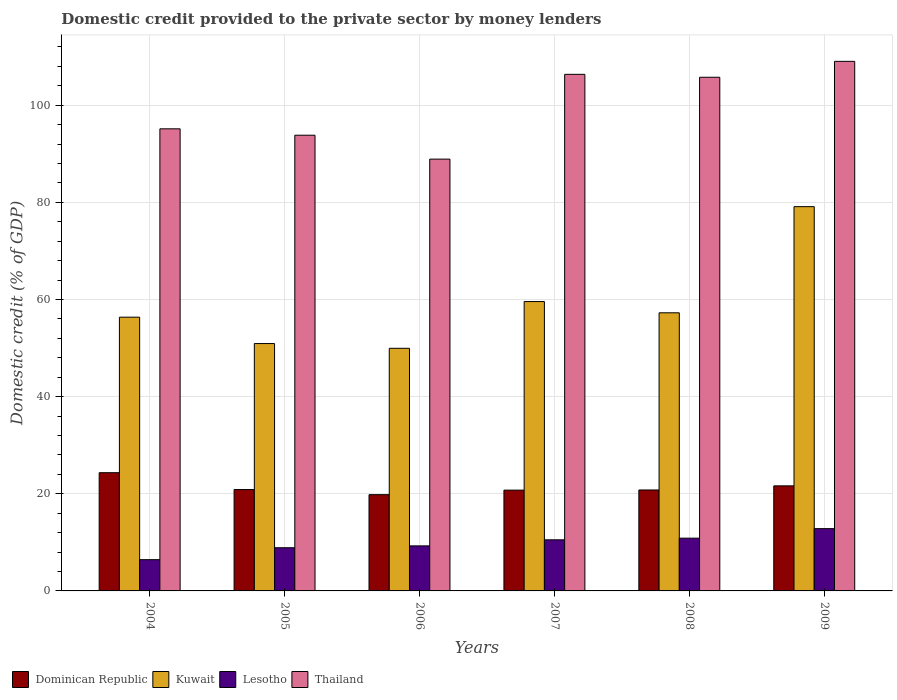How many bars are there on the 5th tick from the left?
Ensure brevity in your answer.  4. How many bars are there on the 6th tick from the right?
Make the answer very short. 4. What is the label of the 1st group of bars from the left?
Provide a succinct answer. 2004. What is the domestic credit provided to the private sector by money lenders in Thailand in 2004?
Give a very brief answer. 95.14. Across all years, what is the maximum domestic credit provided to the private sector by money lenders in Thailand?
Ensure brevity in your answer.  109.04. Across all years, what is the minimum domestic credit provided to the private sector by money lenders in Thailand?
Your answer should be compact. 88.91. In which year was the domestic credit provided to the private sector by money lenders in Kuwait maximum?
Provide a short and direct response. 2009. What is the total domestic credit provided to the private sector by money lenders in Thailand in the graph?
Ensure brevity in your answer.  599.04. What is the difference between the domestic credit provided to the private sector by money lenders in Kuwait in 2005 and that in 2009?
Offer a terse response. -28.19. What is the difference between the domestic credit provided to the private sector by money lenders in Dominican Republic in 2007 and the domestic credit provided to the private sector by money lenders in Kuwait in 2006?
Ensure brevity in your answer.  -29.2. What is the average domestic credit provided to the private sector by money lenders in Thailand per year?
Your answer should be very brief. 99.84. In the year 2009, what is the difference between the domestic credit provided to the private sector by money lenders in Lesotho and domestic credit provided to the private sector by money lenders in Kuwait?
Provide a succinct answer. -66.29. In how many years, is the domestic credit provided to the private sector by money lenders in Dominican Republic greater than 96 %?
Provide a short and direct response. 0. What is the ratio of the domestic credit provided to the private sector by money lenders in Lesotho in 2004 to that in 2006?
Your answer should be very brief. 0.69. What is the difference between the highest and the second highest domestic credit provided to the private sector by money lenders in Lesotho?
Offer a very short reply. 1.96. What is the difference between the highest and the lowest domestic credit provided to the private sector by money lenders in Dominican Republic?
Give a very brief answer. 4.52. Is the sum of the domestic credit provided to the private sector by money lenders in Lesotho in 2004 and 2009 greater than the maximum domestic credit provided to the private sector by money lenders in Thailand across all years?
Ensure brevity in your answer.  No. What does the 2nd bar from the left in 2007 represents?
Keep it short and to the point. Kuwait. What does the 2nd bar from the right in 2004 represents?
Ensure brevity in your answer.  Lesotho. Are all the bars in the graph horizontal?
Offer a very short reply. No. Are the values on the major ticks of Y-axis written in scientific E-notation?
Offer a terse response. No. Does the graph contain any zero values?
Make the answer very short. No. How many legend labels are there?
Give a very brief answer. 4. How are the legend labels stacked?
Provide a succinct answer. Horizontal. What is the title of the graph?
Ensure brevity in your answer.  Domestic credit provided to the private sector by money lenders. Does "Norway" appear as one of the legend labels in the graph?
Offer a terse response. No. What is the label or title of the Y-axis?
Make the answer very short. Domestic credit (% of GDP). What is the Domestic credit (% of GDP) in Dominican Republic in 2004?
Give a very brief answer. 24.34. What is the Domestic credit (% of GDP) of Kuwait in 2004?
Provide a succinct answer. 56.36. What is the Domestic credit (% of GDP) of Lesotho in 2004?
Offer a terse response. 6.44. What is the Domestic credit (% of GDP) of Thailand in 2004?
Give a very brief answer. 95.14. What is the Domestic credit (% of GDP) in Dominican Republic in 2005?
Offer a very short reply. 20.87. What is the Domestic credit (% of GDP) of Kuwait in 2005?
Keep it short and to the point. 50.93. What is the Domestic credit (% of GDP) in Lesotho in 2005?
Provide a short and direct response. 8.89. What is the Domestic credit (% of GDP) of Thailand in 2005?
Your answer should be compact. 93.83. What is the Domestic credit (% of GDP) of Dominican Republic in 2006?
Give a very brief answer. 19.82. What is the Domestic credit (% of GDP) in Kuwait in 2006?
Your answer should be very brief. 49.95. What is the Domestic credit (% of GDP) in Lesotho in 2006?
Keep it short and to the point. 9.27. What is the Domestic credit (% of GDP) of Thailand in 2006?
Make the answer very short. 88.91. What is the Domestic credit (% of GDP) of Dominican Republic in 2007?
Your answer should be compact. 20.75. What is the Domestic credit (% of GDP) in Kuwait in 2007?
Give a very brief answer. 59.58. What is the Domestic credit (% of GDP) in Lesotho in 2007?
Keep it short and to the point. 10.52. What is the Domestic credit (% of GDP) of Thailand in 2007?
Your answer should be compact. 106.36. What is the Domestic credit (% of GDP) in Dominican Republic in 2008?
Your answer should be very brief. 20.79. What is the Domestic credit (% of GDP) of Kuwait in 2008?
Your answer should be very brief. 57.26. What is the Domestic credit (% of GDP) of Lesotho in 2008?
Keep it short and to the point. 10.86. What is the Domestic credit (% of GDP) in Thailand in 2008?
Offer a very short reply. 105.76. What is the Domestic credit (% of GDP) in Dominican Republic in 2009?
Offer a terse response. 21.63. What is the Domestic credit (% of GDP) of Kuwait in 2009?
Give a very brief answer. 79.12. What is the Domestic credit (% of GDP) in Lesotho in 2009?
Offer a terse response. 12.82. What is the Domestic credit (% of GDP) of Thailand in 2009?
Keep it short and to the point. 109.04. Across all years, what is the maximum Domestic credit (% of GDP) in Dominican Republic?
Make the answer very short. 24.34. Across all years, what is the maximum Domestic credit (% of GDP) of Kuwait?
Offer a very short reply. 79.12. Across all years, what is the maximum Domestic credit (% of GDP) in Lesotho?
Give a very brief answer. 12.82. Across all years, what is the maximum Domestic credit (% of GDP) of Thailand?
Keep it short and to the point. 109.04. Across all years, what is the minimum Domestic credit (% of GDP) of Dominican Republic?
Your answer should be compact. 19.82. Across all years, what is the minimum Domestic credit (% of GDP) of Kuwait?
Ensure brevity in your answer.  49.95. Across all years, what is the minimum Domestic credit (% of GDP) of Lesotho?
Provide a succinct answer. 6.44. Across all years, what is the minimum Domestic credit (% of GDP) in Thailand?
Offer a terse response. 88.91. What is the total Domestic credit (% of GDP) in Dominican Republic in the graph?
Ensure brevity in your answer.  128.2. What is the total Domestic credit (% of GDP) in Kuwait in the graph?
Ensure brevity in your answer.  353.21. What is the total Domestic credit (% of GDP) in Lesotho in the graph?
Keep it short and to the point. 58.81. What is the total Domestic credit (% of GDP) of Thailand in the graph?
Your response must be concise. 599.04. What is the difference between the Domestic credit (% of GDP) of Dominican Republic in 2004 and that in 2005?
Provide a short and direct response. 3.47. What is the difference between the Domestic credit (% of GDP) in Kuwait in 2004 and that in 2005?
Make the answer very short. 5.43. What is the difference between the Domestic credit (% of GDP) of Lesotho in 2004 and that in 2005?
Make the answer very short. -2.46. What is the difference between the Domestic credit (% of GDP) of Thailand in 2004 and that in 2005?
Give a very brief answer. 1.31. What is the difference between the Domestic credit (% of GDP) of Dominican Republic in 2004 and that in 2006?
Keep it short and to the point. 4.52. What is the difference between the Domestic credit (% of GDP) of Kuwait in 2004 and that in 2006?
Give a very brief answer. 6.41. What is the difference between the Domestic credit (% of GDP) in Lesotho in 2004 and that in 2006?
Make the answer very short. -2.84. What is the difference between the Domestic credit (% of GDP) of Thailand in 2004 and that in 2006?
Offer a very short reply. 6.24. What is the difference between the Domestic credit (% of GDP) of Dominican Republic in 2004 and that in 2007?
Offer a terse response. 3.59. What is the difference between the Domestic credit (% of GDP) in Kuwait in 2004 and that in 2007?
Your answer should be very brief. -3.22. What is the difference between the Domestic credit (% of GDP) in Lesotho in 2004 and that in 2007?
Ensure brevity in your answer.  -4.09. What is the difference between the Domestic credit (% of GDP) in Thailand in 2004 and that in 2007?
Make the answer very short. -11.22. What is the difference between the Domestic credit (% of GDP) of Dominican Republic in 2004 and that in 2008?
Provide a short and direct response. 3.56. What is the difference between the Domestic credit (% of GDP) of Kuwait in 2004 and that in 2008?
Provide a short and direct response. -0.9. What is the difference between the Domestic credit (% of GDP) in Lesotho in 2004 and that in 2008?
Your response must be concise. -4.43. What is the difference between the Domestic credit (% of GDP) in Thailand in 2004 and that in 2008?
Provide a succinct answer. -10.62. What is the difference between the Domestic credit (% of GDP) in Dominican Republic in 2004 and that in 2009?
Offer a terse response. 2.71. What is the difference between the Domestic credit (% of GDP) in Kuwait in 2004 and that in 2009?
Your response must be concise. -22.76. What is the difference between the Domestic credit (% of GDP) in Lesotho in 2004 and that in 2009?
Give a very brief answer. -6.39. What is the difference between the Domestic credit (% of GDP) of Thailand in 2004 and that in 2009?
Your response must be concise. -13.89. What is the difference between the Domestic credit (% of GDP) in Dominican Republic in 2005 and that in 2006?
Your answer should be very brief. 1.05. What is the difference between the Domestic credit (% of GDP) of Kuwait in 2005 and that in 2006?
Your response must be concise. 0.98. What is the difference between the Domestic credit (% of GDP) in Lesotho in 2005 and that in 2006?
Ensure brevity in your answer.  -0.38. What is the difference between the Domestic credit (% of GDP) in Thailand in 2005 and that in 2006?
Your answer should be very brief. 4.92. What is the difference between the Domestic credit (% of GDP) of Dominican Republic in 2005 and that in 2007?
Give a very brief answer. 0.12. What is the difference between the Domestic credit (% of GDP) in Kuwait in 2005 and that in 2007?
Give a very brief answer. -8.65. What is the difference between the Domestic credit (% of GDP) of Lesotho in 2005 and that in 2007?
Your answer should be very brief. -1.63. What is the difference between the Domestic credit (% of GDP) in Thailand in 2005 and that in 2007?
Keep it short and to the point. -12.53. What is the difference between the Domestic credit (% of GDP) in Dominican Republic in 2005 and that in 2008?
Make the answer very short. 0.09. What is the difference between the Domestic credit (% of GDP) in Kuwait in 2005 and that in 2008?
Make the answer very short. -6.33. What is the difference between the Domestic credit (% of GDP) in Lesotho in 2005 and that in 2008?
Make the answer very short. -1.97. What is the difference between the Domestic credit (% of GDP) in Thailand in 2005 and that in 2008?
Provide a short and direct response. -11.93. What is the difference between the Domestic credit (% of GDP) of Dominican Republic in 2005 and that in 2009?
Provide a succinct answer. -0.76. What is the difference between the Domestic credit (% of GDP) in Kuwait in 2005 and that in 2009?
Provide a short and direct response. -28.19. What is the difference between the Domestic credit (% of GDP) in Lesotho in 2005 and that in 2009?
Provide a short and direct response. -3.93. What is the difference between the Domestic credit (% of GDP) of Thailand in 2005 and that in 2009?
Give a very brief answer. -15.21. What is the difference between the Domestic credit (% of GDP) in Dominican Republic in 2006 and that in 2007?
Ensure brevity in your answer.  -0.94. What is the difference between the Domestic credit (% of GDP) in Kuwait in 2006 and that in 2007?
Ensure brevity in your answer.  -9.63. What is the difference between the Domestic credit (% of GDP) of Lesotho in 2006 and that in 2007?
Provide a short and direct response. -1.25. What is the difference between the Domestic credit (% of GDP) of Thailand in 2006 and that in 2007?
Keep it short and to the point. -17.46. What is the difference between the Domestic credit (% of GDP) in Dominican Republic in 2006 and that in 2008?
Provide a short and direct response. -0.97. What is the difference between the Domestic credit (% of GDP) in Kuwait in 2006 and that in 2008?
Ensure brevity in your answer.  -7.31. What is the difference between the Domestic credit (% of GDP) of Lesotho in 2006 and that in 2008?
Offer a very short reply. -1.59. What is the difference between the Domestic credit (% of GDP) of Thailand in 2006 and that in 2008?
Provide a short and direct response. -16.85. What is the difference between the Domestic credit (% of GDP) of Dominican Republic in 2006 and that in 2009?
Make the answer very short. -1.81. What is the difference between the Domestic credit (% of GDP) of Kuwait in 2006 and that in 2009?
Give a very brief answer. -29.17. What is the difference between the Domestic credit (% of GDP) of Lesotho in 2006 and that in 2009?
Ensure brevity in your answer.  -3.55. What is the difference between the Domestic credit (% of GDP) of Thailand in 2006 and that in 2009?
Ensure brevity in your answer.  -20.13. What is the difference between the Domestic credit (% of GDP) of Dominican Republic in 2007 and that in 2008?
Offer a terse response. -0.03. What is the difference between the Domestic credit (% of GDP) in Kuwait in 2007 and that in 2008?
Provide a short and direct response. 2.31. What is the difference between the Domestic credit (% of GDP) of Lesotho in 2007 and that in 2008?
Your answer should be compact. -0.34. What is the difference between the Domestic credit (% of GDP) in Thailand in 2007 and that in 2008?
Give a very brief answer. 0.6. What is the difference between the Domestic credit (% of GDP) in Dominican Republic in 2007 and that in 2009?
Provide a succinct answer. -0.88. What is the difference between the Domestic credit (% of GDP) of Kuwait in 2007 and that in 2009?
Provide a short and direct response. -19.54. What is the difference between the Domestic credit (% of GDP) of Lesotho in 2007 and that in 2009?
Your response must be concise. -2.3. What is the difference between the Domestic credit (% of GDP) of Thailand in 2007 and that in 2009?
Your answer should be very brief. -2.67. What is the difference between the Domestic credit (% of GDP) in Dominican Republic in 2008 and that in 2009?
Provide a short and direct response. -0.85. What is the difference between the Domestic credit (% of GDP) of Kuwait in 2008 and that in 2009?
Keep it short and to the point. -21.85. What is the difference between the Domestic credit (% of GDP) in Lesotho in 2008 and that in 2009?
Provide a short and direct response. -1.96. What is the difference between the Domestic credit (% of GDP) of Thailand in 2008 and that in 2009?
Offer a terse response. -3.28. What is the difference between the Domestic credit (% of GDP) of Dominican Republic in 2004 and the Domestic credit (% of GDP) of Kuwait in 2005?
Keep it short and to the point. -26.59. What is the difference between the Domestic credit (% of GDP) of Dominican Republic in 2004 and the Domestic credit (% of GDP) of Lesotho in 2005?
Keep it short and to the point. 15.45. What is the difference between the Domestic credit (% of GDP) in Dominican Republic in 2004 and the Domestic credit (% of GDP) in Thailand in 2005?
Your response must be concise. -69.49. What is the difference between the Domestic credit (% of GDP) of Kuwait in 2004 and the Domestic credit (% of GDP) of Lesotho in 2005?
Your answer should be compact. 47.47. What is the difference between the Domestic credit (% of GDP) in Kuwait in 2004 and the Domestic credit (% of GDP) in Thailand in 2005?
Ensure brevity in your answer.  -37.47. What is the difference between the Domestic credit (% of GDP) of Lesotho in 2004 and the Domestic credit (% of GDP) of Thailand in 2005?
Keep it short and to the point. -87.39. What is the difference between the Domestic credit (% of GDP) of Dominican Republic in 2004 and the Domestic credit (% of GDP) of Kuwait in 2006?
Ensure brevity in your answer.  -25.61. What is the difference between the Domestic credit (% of GDP) in Dominican Republic in 2004 and the Domestic credit (% of GDP) in Lesotho in 2006?
Make the answer very short. 15.07. What is the difference between the Domestic credit (% of GDP) of Dominican Republic in 2004 and the Domestic credit (% of GDP) of Thailand in 2006?
Provide a succinct answer. -64.56. What is the difference between the Domestic credit (% of GDP) in Kuwait in 2004 and the Domestic credit (% of GDP) in Lesotho in 2006?
Your response must be concise. 47.09. What is the difference between the Domestic credit (% of GDP) in Kuwait in 2004 and the Domestic credit (% of GDP) in Thailand in 2006?
Provide a short and direct response. -32.54. What is the difference between the Domestic credit (% of GDP) of Lesotho in 2004 and the Domestic credit (% of GDP) of Thailand in 2006?
Offer a very short reply. -82.47. What is the difference between the Domestic credit (% of GDP) in Dominican Republic in 2004 and the Domestic credit (% of GDP) in Kuwait in 2007?
Offer a terse response. -35.24. What is the difference between the Domestic credit (% of GDP) of Dominican Republic in 2004 and the Domestic credit (% of GDP) of Lesotho in 2007?
Provide a short and direct response. 13.82. What is the difference between the Domestic credit (% of GDP) in Dominican Republic in 2004 and the Domestic credit (% of GDP) in Thailand in 2007?
Your response must be concise. -82.02. What is the difference between the Domestic credit (% of GDP) of Kuwait in 2004 and the Domestic credit (% of GDP) of Lesotho in 2007?
Ensure brevity in your answer.  45.84. What is the difference between the Domestic credit (% of GDP) of Kuwait in 2004 and the Domestic credit (% of GDP) of Thailand in 2007?
Your answer should be very brief. -50. What is the difference between the Domestic credit (% of GDP) of Lesotho in 2004 and the Domestic credit (% of GDP) of Thailand in 2007?
Ensure brevity in your answer.  -99.93. What is the difference between the Domestic credit (% of GDP) of Dominican Republic in 2004 and the Domestic credit (% of GDP) of Kuwait in 2008?
Keep it short and to the point. -32.92. What is the difference between the Domestic credit (% of GDP) in Dominican Republic in 2004 and the Domestic credit (% of GDP) in Lesotho in 2008?
Provide a succinct answer. 13.48. What is the difference between the Domestic credit (% of GDP) of Dominican Republic in 2004 and the Domestic credit (% of GDP) of Thailand in 2008?
Ensure brevity in your answer.  -81.42. What is the difference between the Domestic credit (% of GDP) of Kuwait in 2004 and the Domestic credit (% of GDP) of Lesotho in 2008?
Offer a very short reply. 45.5. What is the difference between the Domestic credit (% of GDP) in Kuwait in 2004 and the Domestic credit (% of GDP) in Thailand in 2008?
Give a very brief answer. -49.4. What is the difference between the Domestic credit (% of GDP) in Lesotho in 2004 and the Domestic credit (% of GDP) in Thailand in 2008?
Keep it short and to the point. -99.32. What is the difference between the Domestic credit (% of GDP) of Dominican Republic in 2004 and the Domestic credit (% of GDP) of Kuwait in 2009?
Offer a very short reply. -54.78. What is the difference between the Domestic credit (% of GDP) of Dominican Republic in 2004 and the Domestic credit (% of GDP) of Lesotho in 2009?
Your response must be concise. 11.52. What is the difference between the Domestic credit (% of GDP) in Dominican Republic in 2004 and the Domestic credit (% of GDP) in Thailand in 2009?
Provide a short and direct response. -84.69. What is the difference between the Domestic credit (% of GDP) in Kuwait in 2004 and the Domestic credit (% of GDP) in Lesotho in 2009?
Provide a short and direct response. 43.54. What is the difference between the Domestic credit (% of GDP) of Kuwait in 2004 and the Domestic credit (% of GDP) of Thailand in 2009?
Your answer should be very brief. -52.67. What is the difference between the Domestic credit (% of GDP) in Lesotho in 2004 and the Domestic credit (% of GDP) in Thailand in 2009?
Your answer should be compact. -102.6. What is the difference between the Domestic credit (% of GDP) of Dominican Republic in 2005 and the Domestic credit (% of GDP) of Kuwait in 2006?
Provide a short and direct response. -29.08. What is the difference between the Domestic credit (% of GDP) in Dominican Republic in 2005 and the Domestic credit (% of GDP) in Lesotho in 2006?
Your response must be concise. 11.6. What is the difference between the Domestic credit (% of GDP) of Dominican Republic in 2005 and the Domestic credit (% of GDP) of Thailand in 2006?
Your answer should be very brief. -68.03. What is the difference between the Domestic credit (% of GDP) in Kuwait in 2005 and the Domestic credit (% of GDP) in Lesotho in 2006?
Ensure brevity in your answer.  41.66. What is the difference between the Domestic credit (% of GDP) in Kuwait in 2005 and the Domestic credit (% of GDP) in Thailand in 2006?
Give a very brief answer. -37.97. What is the difference between the Domestic credit (% of GDP) of Lesotho in 2005 and the Domestic credit (% of GDP) of Thailand in 2006?
Your response must be concise. -80.01. What is the difference between the Domestic credit (% of GDP) of Dominican Republic in 2005 and the Domestic credit (% of GDP) of Kuwait in 2007?
Make the answer very short. -38.71. What is the difference between the Domestic credit (% of GDP) of Dominican Republic in 2005 and the Domestic credit (% of GDP) of Lesotho in 2007?
Ensure brevity in your answer.  10.35. What is the difference between the Domestic credit (% of GDP) of Dominican Republic in 2005 and the Domestic credit (% of GDP) of Thailand in 2007?
Give a very brief answer. -85.49. What is the difference between the Domestic credit (% of GDP) of Kuwait in 2005 and the Domestic credit (% of GDP) of Lesotho in 2007?
Keep it short and to the point. 40.41. What is the difference between the Domestic credit (% of GDP) in Kuwait in 2005 and the Domestic credit (% of GDP) in Thailand in 2007?
Ensure brevity in your answer.  -55.43. What is the difference between the Domestic credit (% of GDP) of Lesotho in 2005 and the Domestic credit (% of GDP) of Thailand in 2007?
Your answer should be very brief. -97.47. What is the difference between the Domestic credit (% of GDP) in Dominican Republic in 2005 and the Domestic credit (% of GDP) in Kuwait in 2008?
Your response must be concise. -36.39. What is the difference between the Domestic credit (% of GDP) of Dominican Republic in 2005 and the Domestic credit (% of GDP) of Lesotho in 2008?
Offer a very short reply. 10.01. What is the difference between the Domestic credit (% of GDP) in Dominican Republic in 2005 and the Domestic credit (% of GDP) in Thailand in 2008?
Your response must be concise. -84.89. What is the difference between the Domestic credit (% of GDP) of Kuwait in 2005 and the Domestic credit (% of GDP) of Lesotho in 2008?
Keep it short and to the point. 40.07. What is the difference between the Domestic credit (% of GDP) in Kuwait in 2005 and the Domestic credit (% of GDP) in Thailand in 2008?
Give a very brief answer. -54.83. What is the difference between the Domestic credit (% of GDP) of Lesotho in 2005 and the Domestic credit (% of GDP) of Thailand in 2008?
Your answer should be compact. -96.87. What is the difference between the Domestic credit (% of GDP) in Dominican Republic in 2005 and the Domestic credit (% of GDP) in Kuwait in 2009?
Offer a terse response. -58.25. What is the difference between the Domestic credit (% of GDP) in Dominican Republic in 2005 and the Domestic credit (% of GDP) in Lesotho in 2009?
Make the answer very short. 8.05. What is the difference between the Domestic credit (% of GDP) in Dominican Republic in 2005 and the Domestic credit (% of GDP) in Thailand in 2009?
Offer a very short reply. -88.16. What is the difference between the Domestic credit (% of GDP) of Kuwait in 2005 and the Domestic credit (% of GDP) of Lesotho in 2009?
Ensure brevity in your answer.  38.11. What is the difference between the Domestic credit (% of GDP) of Kuwait in 2005 and the Domestic credit (% of GDP) of Thailand in 2009?
Offer a very short reply. -58.1. What is the difference between the Domestic credit (% of GDP) in Lesotho in 2005 and the Domestic credit (% of GDP) in Thailand in 2009?
Provide a short and direct response. -100.14. What is the difference between the Domestic credit (% of GDP) of Dominican Republic in 2006 and the Domestic credit (% of GDP) of Kuwait in 2007?
Your answer should be compact. -39.76. What is the difference between the Domestic credit (% of GDP) of Dominican Republic in 2006 and the Domestic credit (% of GDP) of Lesotho in 2007?
Give a very brief answer. 9.3. What is the difference between the Domestic credit (% of GDP) of Dominican Republic in 2006 and the Domestic credit (% of GDP) of Thailand in 2007?
Provide a short and direct response. -86.55. What is the difference between the Domestic credit (% of GDP) in Kuwait in 2006 and the Domestic credit (% of GDP) in Lesotho in 2007?
Your answer should be very brief. 39.43. What is the difference between the Domestic credit (% of GDP) of Kuwait in 2006 and the Domestic credit (% of GDP) of Thailand in 2007?
Offer a very short reply. -56.41. What is the difference between the Domestic credit (% of GDP) in Lesotho in 2006 and the Domestic credit (% of GDP) in Thailand in 2007?
Your answer should be compact. -97.09. What is the difference between the Domestic credit (% of GDP) of Dominican Republic in 2006 and the Domestic credit (% of GDP) of Kuwait in 2008?
Provide a succinct answer. -37.45. What is the difference between the Domestic credit (% of GDP) of Dominican Republic in 2006 and the Domestic credit (% of GDP) of Lesotho in 2008?
Give a very brief answer. 8.96. What is the difference between the Domestic credit (% of GDP) in Dominican Republic in 2006 and the Domestic credit (% of GDP) in Thailand in 2008?
Offer a very short reply. -85.94. What is the difference between the Domestic credit (% of GDP) in Kuwait in 2006 and the Domestic credit (% of GDP) in Lesotho in 2008?
Ensure brevity in your answer.  39.09. What is the difference between the Domestic credit (% of GDP) in Kuwait in 2006 and the Domestic credit (% of GDP) in Thailand in 2008?
Your answer should be very brief. -55.81. What is the difference between the Domestic credit (% of GDP) of Lesotho in 2006 and the Domestic credit (% of GDP) of Thailand in 2008?
Make the answer very short. -96.49. What is the difference between the Domestic credit (% of GDP) of Dominican Republic in 2006 and the Domestic credit (% of GDP) of Kuwait in 2009?
Your response must be concise. -59.3. What is the difference between the Domestic credit (% of GDP) in Dominican Republic in 2006 and the Domestic credit (% of GDP) in Lesotho in 2009?
Offer a terse response. 6.99. What is the difference between the Domestic credit (% of GDP) in Dominican Republic in 2006 and the Domestic credit (% of GDP) in Thailand in 2009?
Provide a short and direct response. -89.22. What is the difference between the Domestic credit (% of GDP) of Kuwait in 2006 and the Domestic credit (% of GDP) of Lesotho in 2009?
Your answer should be compact. 37.13. What is the difference between the Domestic credit (% of GDP) of Kuwait in 2006 and the Domestic credit (% of GDP) of Thailand in 2009?
Your answer should be compact. -59.08. What is the difference between the Domestic credit (% of GDP) of Lesotho in 2006 and the Domestic credit (% of GDP) of Thailand in 2009?
Your answer should be very brief. -99.76. What is the difference between the Domestic credit (% of GDP) of Dominican Republic in 2007 and the Domestic credit (% of GDP) of Kuwait in 2008?
Your answer should be compact. -36.51. What is the difference between the Domestic credit (% of GDP) in Dominican Republic in 2007 and the Domestic credit (% of GDP) in Lesotho in 2008?
Make the answer very short. 9.89. What is the difference between the Domestic credit (% of GDP) in Dominican Republic in 2007 and the Domestic credit (% of GDP) in Thailand in 2008?
Your answer should be compact. -85.01. What is the difference between the Domestic credit (% of GDP) of Kuwait in 2007 and the Domestic credit (% of GDP) of Lesotho in 2008?
Provide a succinct answer. 48.72. What is the difference between the Domestic credit (% of GDP) of Kuwait in 2007 and the Domestic credit (% of GDP) of Thailand in 2008?
Ensure brevity in your answer.  -46.18. What is the difference between the Domestic credit (% of GDP) in Lesotho in 2007 and the Domestic credit (% of GDP) in Thailand in 2008?
Make the answer very short. -95.24. What is the difference between the Domestic credit (% of GDP) in Dominican Republic in 2007 and the Domestic credit (% of GDP) in Kuwait in 2009?
Your answer should be compact. -58.37. What is the difference between the Domestic credit (% of GDP) of Dominican Republic in 2007 and the Domestic credit (% of GDP) of Lesotho in 2009?
Provide a short and direct response. 7.93. What is the difference between the Domestic credit (% of GDP) in Dominican Republic in 2007 and the Domestic credit (% of GDP) in Thailand in 2009?
Ensure brevity in your answer.  -88.28. What is the difference between the Domestic credit (% of GDP) in Kuwait in 2007 and the Domestic credit (% of GDP) in Lesotho in 2009?
Your answer should be very brief. 46.75. What is the difference between the Domestic credit (% of GDP) of Kuwait in 2007 and the Domestic credit (% of GDP) of Thailand in 2009?
Keep it short and to the point. -49.46. What is the difference between the Domestic credit (% of GDP) of Lesotho in 2007 and the Domestic credit (% of GDP) of Thailand in 2009?
Your answer should be very brief. -98.51. What is the difference between the Domestic credit (% of GDP) in Dominican Republic in 2008 and the Domestic credit (% of GDP) in Kuwait in 2009?
Make the answer very short. -58.33. What is the difference between the Domestic credit (% of GDP) in Dominican Republic in 2008 and the Domestic credit (% of GDP) in Lesotho in 2009?
Give a very brief answer. 7.96. What is the difference between the Domestic credit (% of GDP) of Dominican Republic in 2008 and the Domestic credit (% of GDP) of Thailand in 2009?
Ensure brevity in your answer.  -88.25. What is the difference between the Domestic credit (% of GDP) of Kuwait in 2008 and the Domestic credit (% of GDP) of Lesotho in 2009?
Ensure brevity in your answer.  44.44. What is the difference between the Domestic credit (% of GDP) of Kuwait in 2008 and the Domestic credit (% of GDP) of Thailand in 2009?
Your response must be concise. -51.77. What is the difference between the Domestic credit (% of GDP) of Lesotho in 2008 and the Domestic credit (% of GDP) of Thailand in 2009?
Give a very brief answer. -98.17. What is the average Domestic credit (% of GDP) of Dominican Republic per year?
Your response must be concise. 21.37. What is the average Domestic credit (% of GDP) of Kuwait per year?
Provide a succinct answer. 58.87. What is the average Domestic credit (% of GDP) of Lesotho per year?
Provide a short and direct response. 9.8. What is the average Domestic credit (% of GDP) in Thailand per year?
Provide a succinct answer. 99.84. In the year 2004, what is the difference between the Domestic credit (% of GDP) in Dominican Republic and Domestic credit (% of GDP) in Kuwait?
Your answer should be very brief. -32.02. In the year 2004, what is the difference between the Domestic credit (% of GDP) of Dominican Republic and Domestic credit (% of GDP) of Lesotho?
Make the answer very short. 17.91. In the year 2004, what is the difference between the Domestic credit (% of GDP) of Dominican Republic and Domestic credit (% of GDP) of Thailand?
Ensure brevity in your answer.  -70.8. In the year 2004, what is the difference between the Domestic credit (% of GDP) of Kuwait and Domestic credit (% of GDP) of Lesotho?
Ensure brevity in your answer.  49.93. In the year 2004, what is the difference between the Domestic credit (% of GDP) in Kuwait and Domestic credit (% of GDP) in Thailand?
Keep it short and to the point. -38.78. In the year 2004, what is the difference between the Domestic credit (% of GDP) in Lesotho and Domestic credit (% of GDP) in Thailand?
Offer a terse response. -88.71. In the year 2005, what is the difference between the Domestic credit (% of GDP) in Dominican Republic and Domestic credit (% of GDP) in Kuwait?
Provide a succinct answer. -30.06. In the year 2005, what is the difference between the Domestic credit (% of GDP) of Dominican Republic and Domestic credit (% of GDP) of Lesotho?
Your answer should be very brief. 11.98. In the year 2005, what is the difference between the Domestic credit (% of GDP) in Dominican Republic and Domestic credit (% of GDP) in Thailand?
Provide a succinct answer. -72.96. In the year 2005, what is the difference between the Domestic credit (% of GDP) in Kuwait and Domestic credit (% of GDP) in Lesotho?
Ensure brevity in your answer.  42.04. In the year 2005, what is the difference between the Domestic credit (% of GDP) of Kuwait and Domestic credit (% of GDP) of Thailand?
Ensure brevity in your answer.  -42.9. In the year 2005, what is the difference between the Domestic credit (% of GDP) of Lesotho and Domestic credit (% of GDP) of Thailand?
Your answer should be very brief. -84.94. In the year 2006, what is the difference between the Domestic credit (% of GDP) in Dominican Republic and Domestic credit (% of GDP) in Kuwait?
Keep it short and to the point. -30.14. In the year 2006, what is the difference between the Domestic credit (% of GDP) in Dominican Republic and Domestic credit (% of GDP) in Lesotho?
Give a very brief answer. 10.54. In the year 2006, what is the difference between the Domestic credit (% of GDP) of Dominican Republic and Domestic credit (% of GDP) of Thailand?
Ensure brevity in your answer.  -69.09. In the year 2006, what is the difference between the Domestic credit (% of GDP) in Kuwait and Domestic credit (% of GDP) in Lesotho?
Give a very brief answer. 40.68. In the year 2006, what is the difference between the Domestic credit (% of GDP) in Kuwait and Domestic credit (% of GDP) in Thailand?
Provide a succinct answer. -38.95. In the year 2006, what is the difference between the Domestic credit (% of GDP) in Lesotho and Domestic credit (% of GDP) in Thailand?
Offer a very short reply. -79.63. In the year 2007, what is the difference between the Domestic credit (% of GDP) of Dominican Republic and Domestic credit (% of GDP) of Kuwait?
Your answer should be compact. -38.83. In the year 2007, what is the difference between the Domestic credit (% of GDP) of Dominican Republic and Domestic credit (% of GDP) of Lesotho?
Make the answer very short. 10.23. In the year 2007, what is the difference between the Domestic credit (% of GDP) of Dominican Republic and Domestic credit (% of GDP) of Thailand?
Provide a succinct answer. -85.61. In the year 2007, what is the difference between the Domestic credit (% of GDP) in Kuwait and Domestic credit (% of GDP) in Lesotho?
Provide a succinct answer. 49.06. In the year 2007, what is the difference between the Domestic credit (% of GDP) in Kuwait and Domestic credit (% of GDP) in Thailand?
Your answer should be very brief. -46.78. In the year 2007, what is the difference between the Domestic credit (% of GDP) in Lesotho and Domestic credit (% of GDP) in Thailand?
Offer a very short reply. -95.84. In the year 2008, what is the difference between the Domestic credit (% of GDP) in Dominican Republic and Domestic credit (% of GDP) in Kuwait?
Give a very brief answer. -36.48. In the year 2008, what is the difference between the Domestic credit (% of GDP) of Dominican Republic and Domestic credit (% of GDP) of Lesotho?
Your response must be concise. 9.92. In the year 2008, what is the difference between the Domestic credit (% of GDP) in Dominican Republic and Domestic credit (% of GDP) in Thailand?
Your answer should be very brief. -84.97. In the year 2008, what is the difference between the Domestic credit (% of GDP) in Kuwait and Domestic credit (% of GDP) in Lesotho?
Your answer should be compact. 46.4. In the year 2008, what is the difference between the Domestic credit (% of GDP) in Kuwait and Domestic credit (% of GDP) in Thailand?
Provide a succinct answer. -48.5. In the year 2008, what is the difference between the Domestic credit (% of GDP) in Lesotho and Domestic credit (% of GDP) in Thailand?
Ensure brevity in your answer.  -94.9. In the year 2009, what is the difference between the Domestic credit (% of GDP) in Dominican Republic and Domestic credit (% of GDP) in Kuwait?
Your answer should be very brief. -57.49. In the year 2009, what is the difference between the Domestic credit (% of GDP) of Dominican Republic and Domestic credit (% of GDP) of Lesotho?
Offer a very short reply. 8.81. In the year 2009, what is the difference between the Domestic credit (% of GDP) in Dominican Republic and Domestic credit (% of GDP) in Thailand?
Offer a very short reply. -87.4. In the year 2009, what is the difference between the Domestic credit (% of GDP) of Kuwait and Domestic credit (% of GDP) of Lesotho?
Provide a short and direct response. 66.29. In the year 2009, what is the difference between the Domestic credit (% of GDP) of Kuwait and Domestic credit (% of GDP) of Thailand?
Provide a succinct answer. -29.92. In the year 2009, what is the difference between the Domestic credit (% of GDP) of Lesotho and Domestic credit (% of GDP) of Thailand?
Ensure brevity in your answer.  -96.21. What is the ratio of the Domestic credit (% of GDP) of Dominican Republic in 2004 to that in 2005?
Give a very brief answer. 1.17. What is the ratio of the Domestic credit (% of GDP) of Kuwait in 2004 to that in 2005?
Make the answer very short. 1.11. What is the ratio of the Domestic credit (% of GDP) in Lesotho in 2004 to that in 2005?
Your answer should be compact. 0.72. What is the ratio of the Domestic credit (% of GDP) in Dominican Republic in 2004 to that in 2006?
Your answer should be very brief. 1.23. What is the ratio of the Domestic credit (% of GDP) of Kuwait in 2004 to that in 2006?
Offer a very short reply. 1.13. What is the ratio of the Domestic credit (% of GDP) in Lesotho in 2004 to that in 2006?
Provide a succinct answer. 0.69. What is the ratio of the Domestic credit (% of GDP) in Thailand in 2004 to that in 2006?
Make the answer very short. 1.07. What is the ratio of the Domestic credit (% of GDP) of Dominican Republic in 2004 to that in 2007?
Ensure brevity in your answer.  1.17. What is the ratio of the Domestic credit (% of GDP) of Kuwait in 2004 to that in 2007?
Your response must be concise. 0.95. What is the ratio of the Domestic credit (% of GDP) in Lesotho in 2004 to that in 2007?
Provide a succinct answer. 0.61. What is the ratio of the Domestic credit (% of GDP) in Thailand in 2004 to that in 2007?
Make the answer very short. 0.89. What is the ratio of the Domestic credit (% of GDP) of Dominican Republic in 2004 to that in 2008?
Make the answer very short. 1.17. What is the ratio of the Domestic credit (% of GDP) in Kuwait in 2004 to that in 2008?
Make the answer very short. 0.98. What is the ratio of the Domestic credit (% of GDP) of Lesotho in 2004 to that in 2008?
Make the answer very short. 0.59. What is the ratio of the Domestic credit (% of GDP) of Thailand in 2004 to that in 2008?
Provide a short and direct response. 0.9. What is the ratio of the Domestic credit (% of GDP) of Dominican Republic in 2004 to that in 2009?
Offer a very short reply. 1.13. What is the ratio of the Domestic credit (% of GDP) in Kuwait in 2004 to that in 2009?
Provide a short and direct response. 0.71. What is the ratio of the Domestic credit (% of GDP) of Lesotho in 2004 to that in 2009?
Provide a succinct answer. 0.5. What is the ratio of the Domestic credit (% of GDP) of Thailand in 2004 to that in 2009?
Offer a terse response. 0.87. What is the ratio of the Domestic credit (% of GDP) of Dominican Republic in 2005 to that in 2006?
Your answer should be compact. 1.05. What is the ratio of the Domestic credit (% of GDP) in Kuwait in 2005 to that in 2006?
Offer a terse response. 1.02. What is the ratio of the Domestic credit (% of GDP) in Lesotho in 2005 to that in 2006?
Ensure brevity in your answer.  0.96. What is the ratio of the Domestic credit (% of GDP) in Thailand in 2005 to that in 2006?
Offer a very short reply. 1.06. What is the ratio of the Domestic credit (% of GDP) of Dominican Republic in 2005 to that in 2007?
Provide a short and direct response. 1.01. What is the ratio of the Domestic credit (% of GDP) of Kuwait in 2005 to that in 2007?
Offer a very short reply. 0.85. What is the ratio of the Domestic credit (% of GDP) in Lesotho in 2005 to that in 2007?
Make the answer very short. 0.85. What is the ratio of the Domestic credit (% of GDP) in Thailand in 2005 to that in 2007?
Provide a short and direct response. 0.88. What is the ratio of the Domestic credit (% of GDP) of Kuwait in 2005 to that in 2008?
Keep it short and to the point. 0.89. What is the ratio of the Domestic credit (% of GDP) of Lesotho in 2005 to that in 2008?
Keep it short and to the point. 0.82. What is the ratio of the Domestic credit (% of GDP) in Thailand in 2005 to that in 2008?
Provide a succinct answer. 0.89. What is the ratio of the Domestic credit (% of GDP) in Dominican Republic in 2005 to that in 2009?
Offer a terse response. 0.96. What is the ratio of the Domestic credit (% of GDP) in Kuwait in 2005 to that in 2009?
Your answer should be very brief. 0.64. What is the ratio of the Domestic credit (% of GDP) in Lesotho in 2005 to that in 2009?
Provide a succinct answer. 0.69. What is the ratio of the Domestic credit (% of GDP) of Thailand in 2005 to that in 2009?
Give a very brief answer. 0.86. What is the ratio of the Domestic credit (% of GDP) in Dominican Republic in 2006 to that in 2007?
Your answer should be very brief. 0.95. What is the ratio of the Domestic credit (% of GDP) of Kuwait in 2006 to that in 2007?
Your answer should be compact. 0.84. What is the ratio of the Domestic credit (% of GDP) in Lesotho in 2006 to that in 2007?
Keep it short and to the point. 0.88. What is the ratio of the Domestic credit (% of GDP) of Thailand in 2006 to that in 2007?
Keep it short and to the point. 0.84. What is the ratio of the Domestic credit (% of GDP) of Dominican Republic in 2006 to that in 2008?
Your answer should be compact. 0.95. What is the ratio of the Domestic credit (% of GDP) in Kuwait in 2006 to that in 2008?
Offer a terse response. 0.87. What is the ratio of the Domestic credit (% of GDP) in Lesotho in 2006 to that in 2008?
Ensure brevity in your answer.  0.85. What is the ratio of the Domestic credit (% of GDP) of Thailand in 2006 to that in 2008?
Your response must be concise. 0.84. What is the ratio of the Domestic credit (% of GDP) in Dominican Republic in 2006 to that in 2009?
Your answer should be compact. 0.92. What is the ratio of the Domestic credit (% of GDP) in Kuwait in 2006 to that in 2009?
Provide a succinct answer. 0.63. What is the ratio of the Domestic credit (% of GDP) of Lesotho in 2006 to that in 2009?
Offer a terse response. 0.72. What is the ratio of the Domestic credit (% of GDP) in Thailand in 2006 to that in 2009?
Give a very brief answer. 0.82. What is the ratio of the Domestic credit (% of GDP) in Dominican Republic in 2007 to that in 2008?
Your response must be concise. 1. What is the ratio of the Domestic credit (% of GDP) in Kuwait in 2007 to that in 2008?
Provide a short and direct response. 1.04. What is the ratio of the Domestic credit (% of GDP) in Lesotho in 2007 to that in 2008?
Your answer should be compact. 0.97. What is the ratio of the Domestic credit (% of GDP) in Dominican Republic in 2007 to that in 2009?
Your response must be concise. 0.96. What is the ratio of the Domestic credit (% of GDP) in Kuwait in 2007 to that in 2009?
Give a very brief answer. 0.75. What is the ratio of the Domestic credit (% of GDP) of Lesotho in 2007 to that in 2009?
Offer a very short reply. 0.82. What is the ratio of the Domestic credit (% of GDP) of Thailand in 2007 to that in 2009?
Your answer should be compact. 0.98. What is the ratio of the Domestic credit (% of GDP) of Dominican Republic in 2008 to that in 2009?
Offer a very short reply. 0.96. What is the ratio of the Domestic credit (% of GDP) in Kuwait in 2008 to that in 2009?
Provide a succinct answer. 0.72. What is the ratio of the Domestic credit (% of GDP) in Lesotho in 2008 to that in 2009?
Provide a short and direct response. 0.85. What is the ratio of the Domestic credit (% of GDP) of Thailand in 2008 to that in 2009?
Give a very brief answer. 0.97. What is the difference between the highest and the second highest Domestic credit (% of GDP) in Dominican Republic?
Your answer should be very brief. 2.71. What is the difference between the highest and the second highest Domestic credit (% of GDP) of Kuwait?
Your answer should be very brief. 19.54. What is the difference between the highest and the second highest Domestic credit (% of GDP) of Lesotho?
Offer a very short reply. 1.96. What is the difference between the highest and the second highest Domestic credit (% of GDP) of Thailand?
Your answer should be very brief. 2.67. What is the difference between the highest and the lowest Domestic credit (% of GDP) in Dominican Republic?
Your answer should be compact. 4.52. What is the difference between the highest and the lowest Domestic credit (% of GDP) of Kuwait?
Provide a succinct answer. 29.17. What is the difference between the highest and the lowest Domestic credit (% of GDP) of Lesotho?
Provide a succinct answer. 6.39. What is the difference between the highest and the lowest Domestic credit (% of GDP) in Thailand?
Provide a short and direct response. 20.13. 